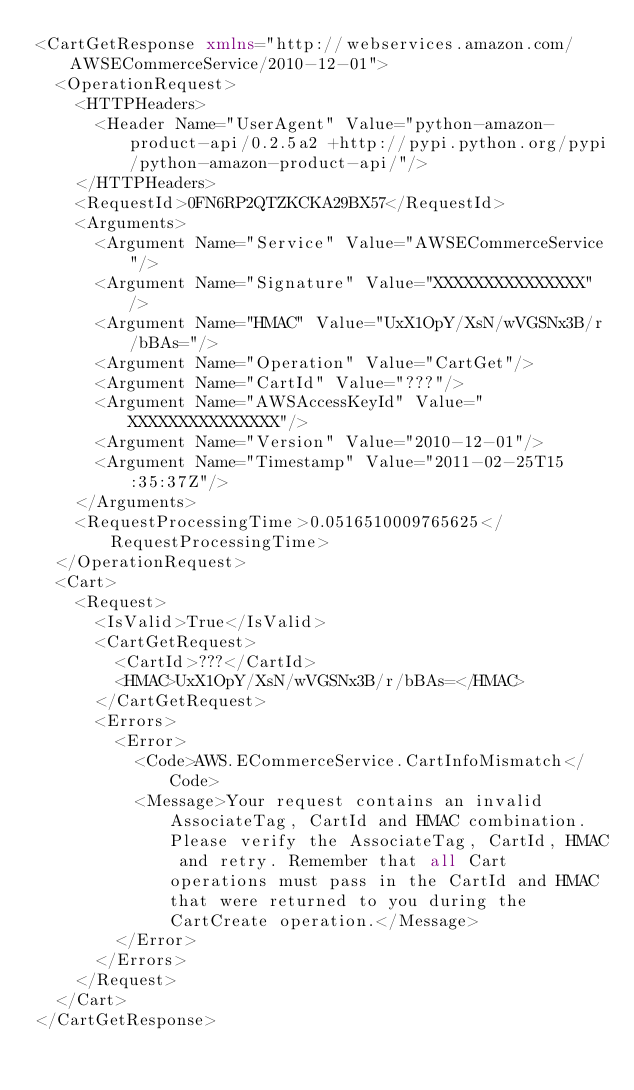<code> <loc_0><loc_0><loc_500><loc_500><_XML_><CartGetResponse xmlns="http://webservices.amazon.com/AWSECommerceService/2010-12-01">
  <OperationRequest>
    <HTTPHeaders>
      <Header Name="UserAgent" Value="python-amazon-product-api/0.2.5a2 +http://pypi.python.org/pypi/python-amazon-product-api/"/>
    </HTTPHeaders>
    <RequestId>0FN6RP2QTZKCKA29BX57</RequestId>
    <Arguments>
      <Argument Name="Service" Value="AWSECommerceService"/>
      <Argument Name="Signature" Value="XXXXXXXXXXXXXXX"/>
      <Argument Name="HMAC" Value="UxX1OpY/XsN/wVGSNx3B/r/bBAs="/>
      <Argument Name="Operation" Value="CartGet"/>
      <Argument Name="CartId" Value="???"/>
      <Argument Name="AWSAccessKeyId" Value="XXXXXXXXXXXXXXX"/>
      <Argument Name="Version" Value="2010-12-01"/>
      <Argument Name="Timestamp" Value="2011-02-25T15:35:37Z"/>
    </Arguments>
    <RequestProcessingTime>0.0516510009765625</RequestProcessingTime>
  </OperationRequest>
  <Cart>
    <Request>
      <IsValid>True</IsValid>
      <CartGetRequest>
        <CartId>???</CartId>
        <HMAC>UxX1OpY/XsN/wVGSNx3B/r/bBAs=</HMAC>
      </CartGetRequest>
      <Errors>
        <Error>
          <Code>AWS.ECommerceService.CartInfoMismatch</Code>
          <Message>Your request contains an invalid AssociateTag, CartId and HMAC combination. Please verify the AssociateTag, CartId, HMAC and retry. Remember that all Cart operations must pass in the CartId and HMAC that were returned to you during the CartCreate operation.</Message>
        </Error>
      </Errors>
    </Request>
  </Cart>
</CartGetResponse>
</code> 